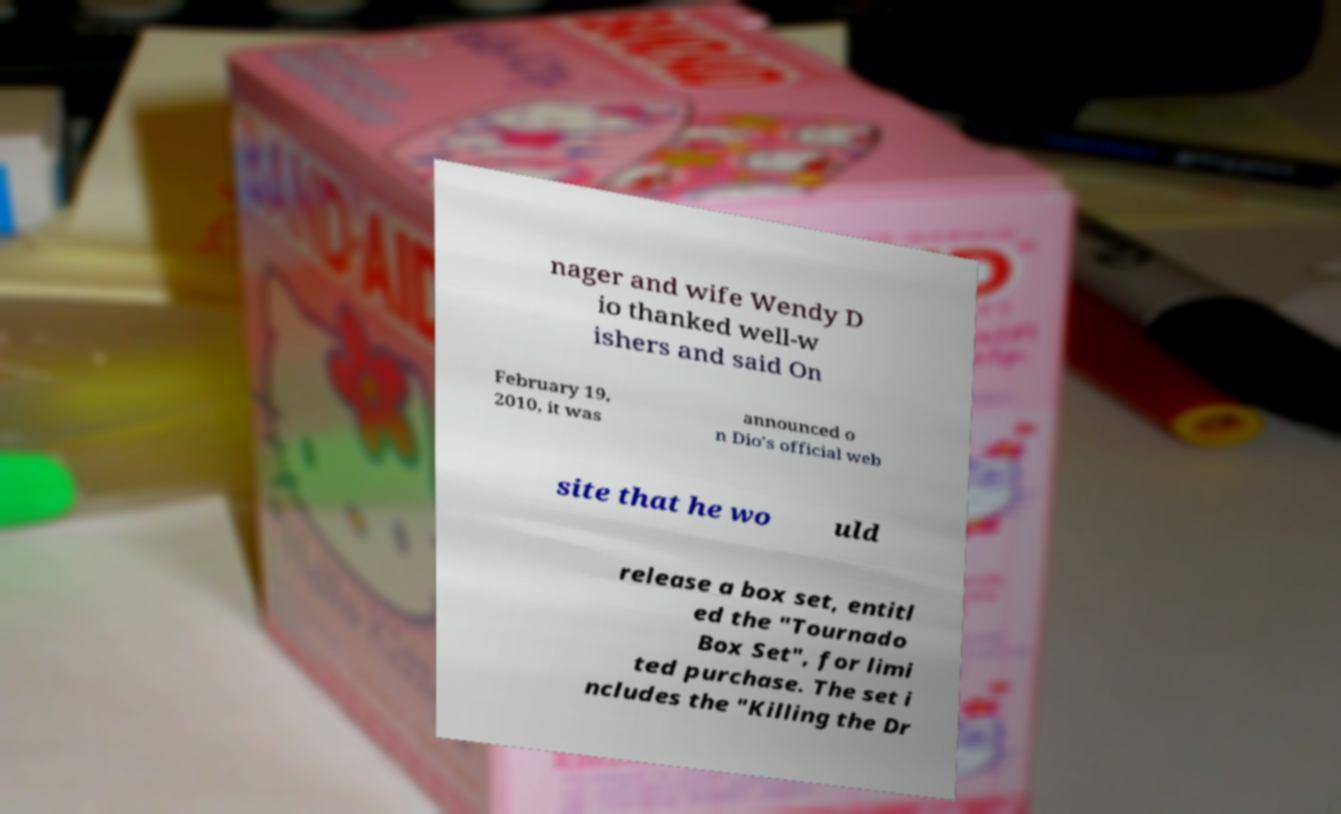Could you extract and type out the text from this image? nager and wife Wendy D io thanked well-w ishers and said On February 19, 2010, it was announced o n Dio's official web site that he wo uld release a box set, entitl ed the "Tournado Box Set", for limi ted purchase. The set i ncludes the "Killing the Dr 